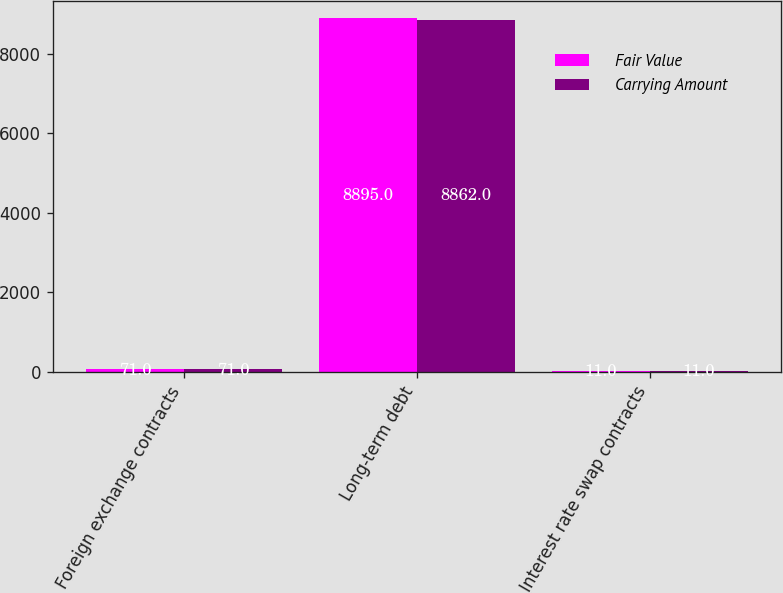Convert chart to OTSL. <chart><loc_0><loc_0><loc_500><loc_500><stacked_bar_chart><ecel><fcel>Foreign exchange contracts<fcel>Long-term debt<fcel>Interest rate swap contracts<nl><fcel>Fair Value<fcel>71<fcel>8895<fcel>11<nl><fcel>Carrying Amount<fcel>71<fcel>8862<fcel>11<nl></chart> 